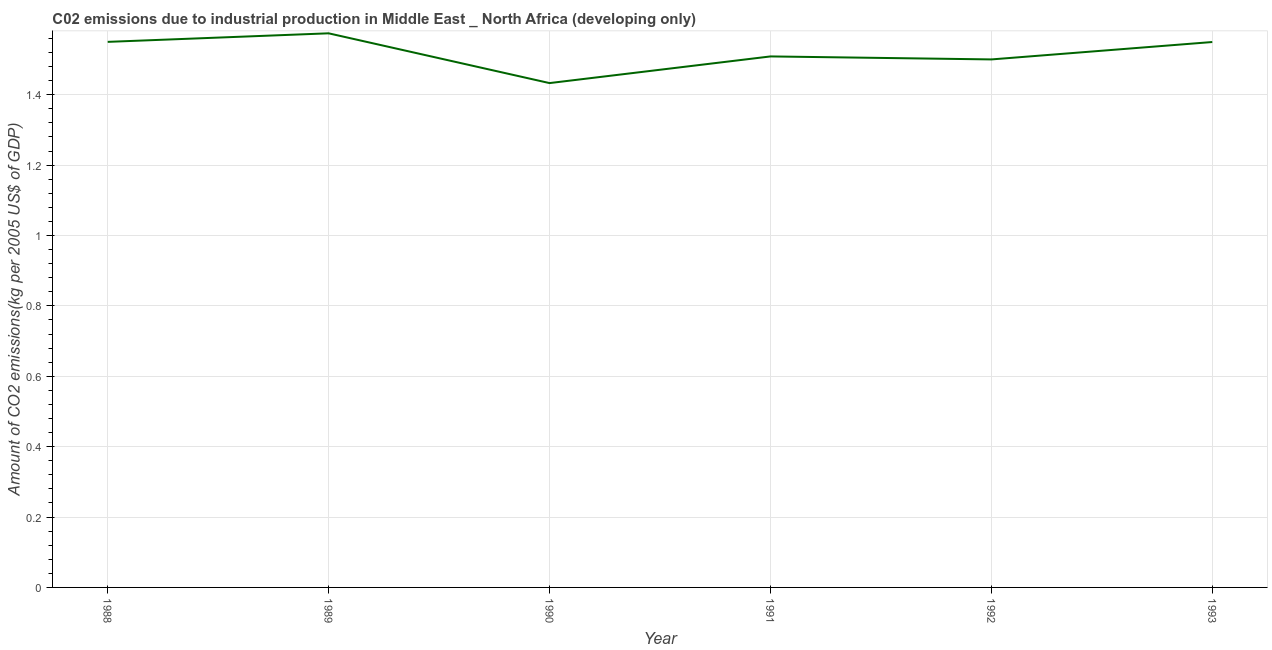What is the amount of co2 emissions in 1988?
Provide a short and direct response. 1.55. Across all years, what is the maximum amount of co2 emissions?
Provide a short and direct response. 1.57. Across all years, what is the minimum amount of co2 emissions?
Your answer should be very brief. 1.43. In which year was the amount of co2 emissions maximum?
Offer a terse response. 1989. In which year was the amount of co2 emissions minimum?
Give a very brief answer. 1990. What is the sum of the amount of co2 emissions?
Make the answer very short. 9.12. What is the difference between the amount of co2 emissions in 1991 and 1993?
Keep it short and to the point. -0.04. What is the average amount of co2 emissions per year?
Give a very brief answer. 1.52. What is the median amount of co2 emissions?
Your answer should be very brief. 1.53. In how many years, is the amount of co2 emissions greater than 0.48000000000000004 kg per 2005 US$ of GDP?
Give a very brief answer. 6. What is the ratio of the amount of co2 emissions in 1988 to that in 1993?
Keep it short and to the point. 1. Is the difference between the amount of co2 emissions in 1991 and 1993 greater than the difference between any two years?
Offer a terse response. No. What is the difference between the highest and the second highest amount of co2 emissions?
Offer a very short reply. 0.02. What is the difference between the highest and the lowest amount of co2 emissions?
Your response must be concise. 0.14. In how many years, is the amount of co2 emissions greater than the average amount of co2 emissions taken over all years?
Give a very brief answer. 3. Does the amount of co2 emissions monotonically increase over the years?
Make the answer very short. No. Are the values on the major ticks of Y-axis written in scientific E-notation?
Make the answer very short. No. Does the graph contain any zero values?
Ensure brevity in your answer.  No. What is the title of the graph?
Provide a short and direct response. C02 emissions due to industrial production in Middle East _ North Africa (developing only). What is the label or title of the X-axis?
Provide a succinct answer. Year. What is the label or title of the Y-axis?
Ensure brevity in your answer.  Amount of CO2 emissions(kg per 2005 US$ of GDP). What is the Amount of CO2 emissions(kg per 2005 US$ of GDP) in 1988?
Provide a short and direct response. 1.55. What is the Amount of CO2 emissions(kg per 2005 US$ of GDP) in 1989?
Offer a very short reply. 1.57. What is the Amount of CO2 emissions(kg per 2005 US$ of GDP) in 1990?
Offer a very short reply. 1.43. What is the Amount of CO2 emissions(kg per 2005 US$ of GDP) of 1991?
Give a very brief answer. 1.51. What is the Amount of CO2 emissions(kg per 2005 US$ of GDP) of 1992?
Offer a very short reply. 1.5. What is the Amount of CO2 emissions(kg per 2005 US$ of GDP) of 1993?
Your response must be concise. 1.55. What is the difference between the Amount of CO2 emissions(kg per 2005 US$ of GDP) in 1988 and 1989?
Keep it short and to the point. -0.02. What is the difference between the Amount of CO2 emissions(kg per 2005 US$ of GDP) in 1988 and 1990?
Your response must be concise. 0.12. What is the difference between the Amount of CO2 emissions(kg per 2005 US$ of GDP) in 1988 and 1991?
Make the answer very short. 0.04. What is the difference between the Amount of CO2 emissions(kg per 2005 US$ of GDP) in 1988 and 1992?
Ensure brevity in your answer.  0.05. What is the difference between the Amount of CO2 emissions(kg per 2005 US$ of GDP) in 1988 and 1993?
Make the answer very short. 0. What is the difference between the Amount of CO2 emissions(kg per 2005 US$ of GDP) in 1989 and 1990?
Offer a very short reply. 0.14. What is the difference between the Amount of CO2 emissions(kg per 2005 US$ of GDP) in 1989 and 1991?
Your answer should be very brief. 0.07. What is the difference between the Amount of CO2 emissions(kg per 2005 US$ of GDP) in 1989 and 1992?
Give a very brief answer. 0.07. What is the difference between the Amount of CO2 emissions(kg per 2005 US$ of GDP) in 1989 and 1993?
Ensure brevity in your answer.  0.02. What is the difference between the Amount of CO2 emissions(kg per 2005 US$ of GDP) in 1990 and 1991?
Your response must be concise. -0.08. What is the difference between the Amount of CO2 emissions(kg per 2005 US$ of GDP) in 1990 and 1992?
Ensure brevity in your answer.  -0.07. What is the difference between the Amount of CO2 emissions(kg per 2005 US$ of GDP) in 1990 and 1993?
Keep it short and to the point. -0.12. What is the difference between the Amount of CO2 emissions(kg per 2005 US$ of GDP) in 1991 and 1992?
Your answer should be very brief. 0.01. What is the difference between the Amount of CO2 emissions(kg per 2005 US$ of GDP) in 1991 and 1993?
Ensure brevity in your answer.  -0.04. What is the difference between the Amount of CO2 emissions(kg per 2005 US$ of GDP) in 1992 and 1993?
Provide a succinct answer. -0.05. What is the ratio of the Amount of CO2 emissions(kg per 2005 US$ of GDP) in 1988 to that in 1989?
Make the answer very short. 0.98. What is the ratio of the Amount of CO2 emissions(kg per 2005 US$ of GDP) in 1988 to that in 1990?
Keep it short and to the point. 1.08. What is the ratio of the Amount of CO2 emissions(kg per 2005 US$ of GDP) in 1988 to that in 1992?
Ensure brevity in your answer.  1.03. What is the ratio of the Amount of CO2 emissions(kg per 2005 US$ of GDP) in 1989 to that in 1990?
Your answer should be compact. 1.1. What is the ratio of the Amount of CO2 emissions(kg per 2005 US$ of GDP) in 1989 to that in 1991?
Your answer should be very brief. 1.04. What is the ratio of the Amount of CO2 emissions(kg per 2005 US$ of GDP) in 1989 to that in 1992?
Provide a short and direct response. 1.05. What is the ratio of the Amount of CO2 emissions(kg per 2005 US$ of GDP) in 1990 to that in 1992?
Your answer should be compact. 0.95. What is the ratio of the Amount of CO2 emissions(kg per 2005 US$ of GDP) in 1990 to that in 1993?
Your response must be concise. 0.93. What is the ratio of the Amount of CO2 emissions(kg per 2005 US$ of GDP) in 1991 to that in 1992?
Ensure brevity in your answer.  1.01. What is the ratio of the Amount of CO2 emissions(kg per 2005 US$ of GDP) in 1991 to that in 1993?
Your answer should be compact. 0.97. What is the ratio of the Amount of CO2 emissions(kg per 2005 US$ of GDP) in 1992 to that in 1993?
Provide a succinct answer. 0.97. 